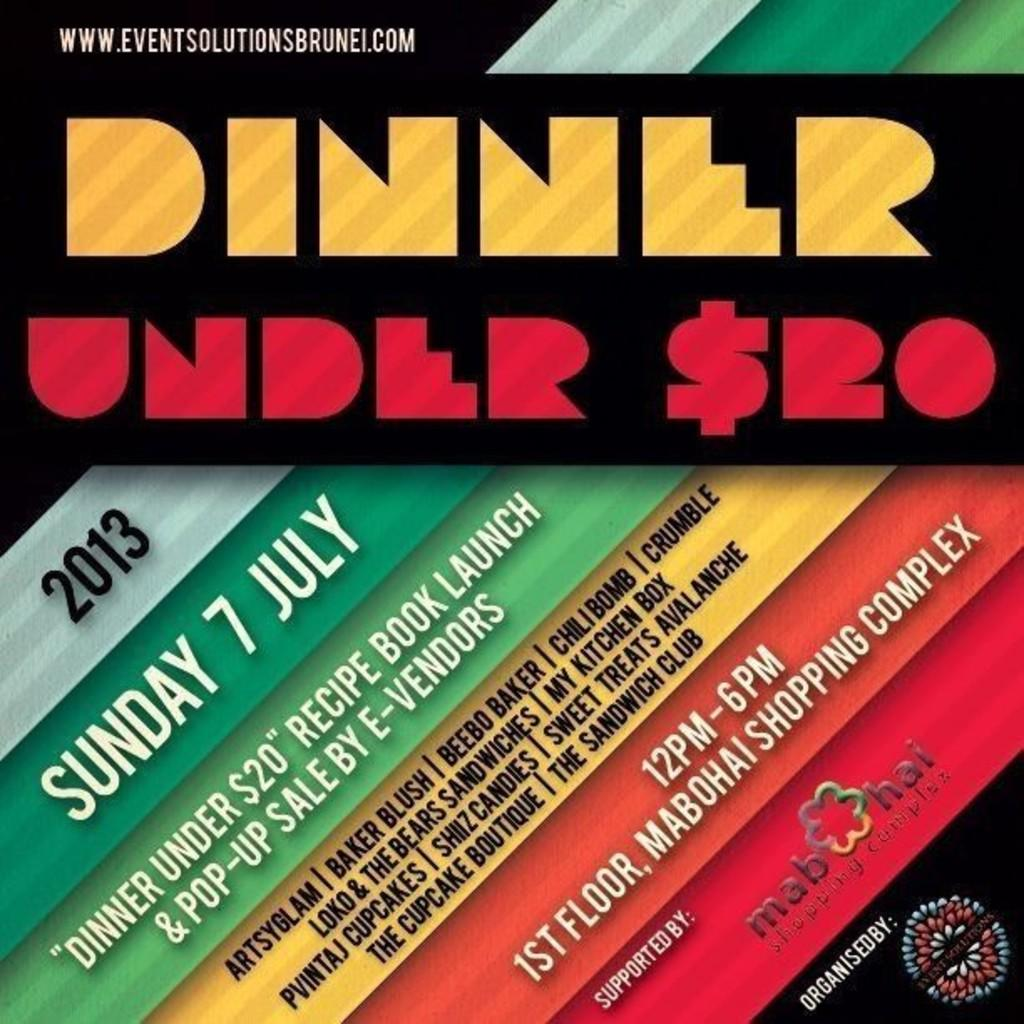<image>
Give a short and clear explanation of the subsequent image. Poster showing the year 2013 and the date is Sunday 7 July. 